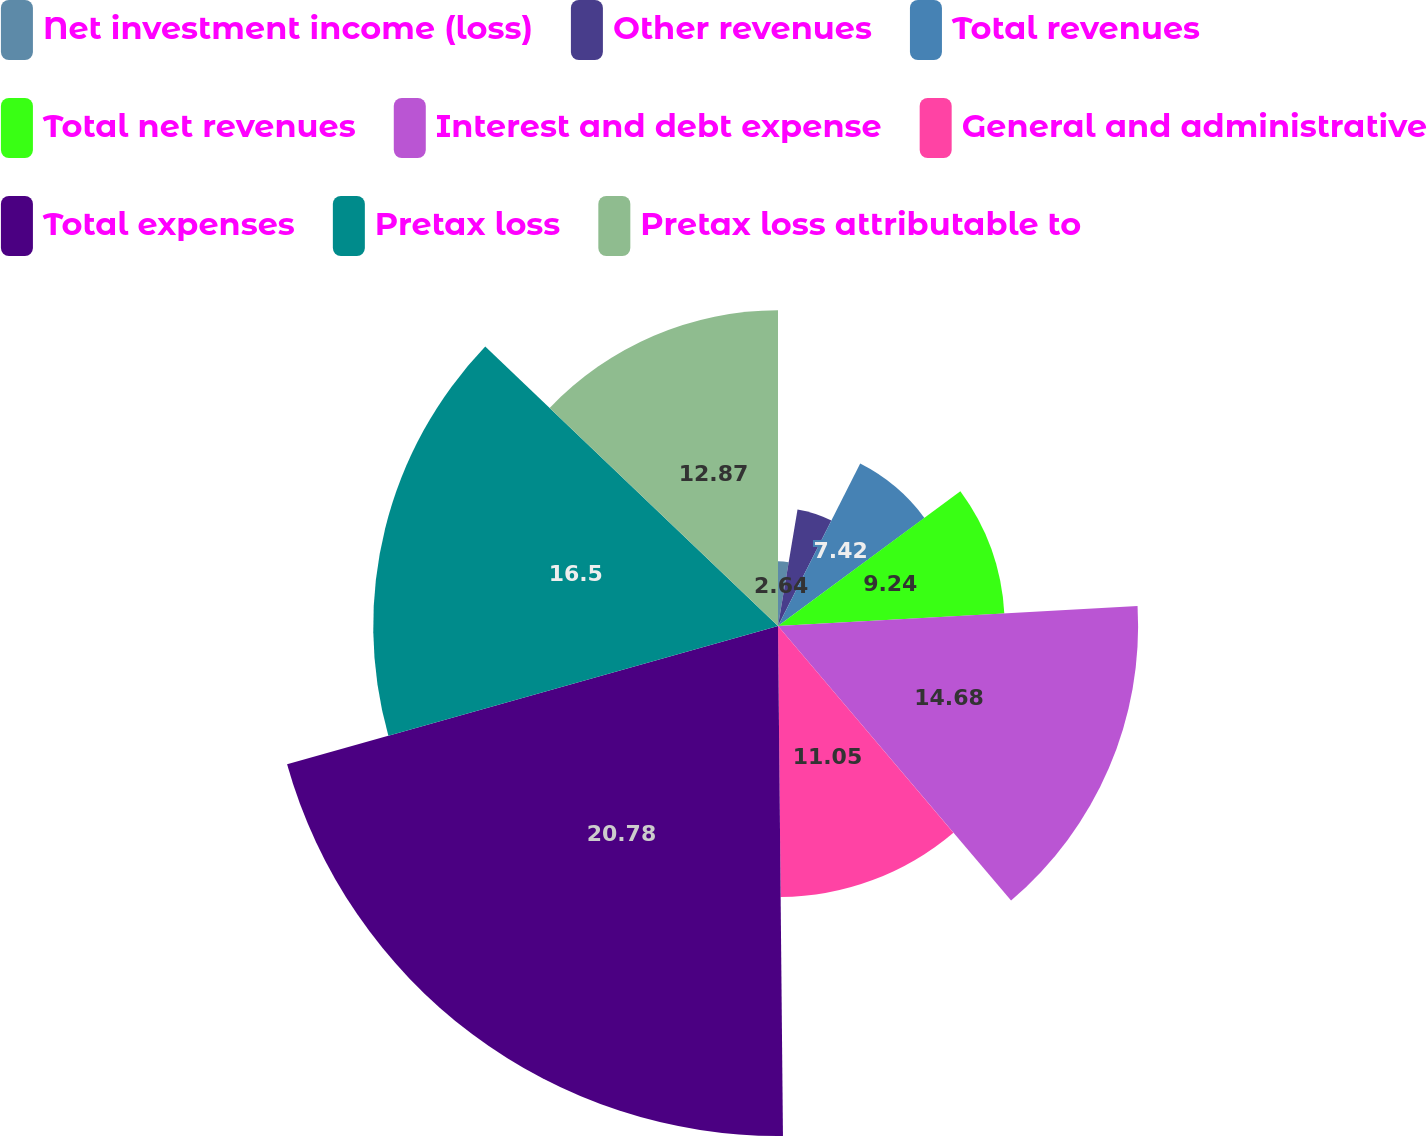Convert chart to OTSL. <chart><loc_0><loc_0><loc_500><loc_500><pie_chart><fcel>Net investment income (loss)<fcel>Other revenues<fcel>Total revenues<fcel>Total net revenues<fcel>Interest and debt expense<fcel>General and administrative<fcel>Total expenses<fcel>Pretax loss<fcel>Pretax loss attributable to<nl><fcel>2.64%<fcel>4.82%<fcel>7.42%<fcel>9.24%<fcel>14.68%<fcel>11.05%<fcel>20.79%<fcel>16.5%<fcel>12.87%<nl></chart> 